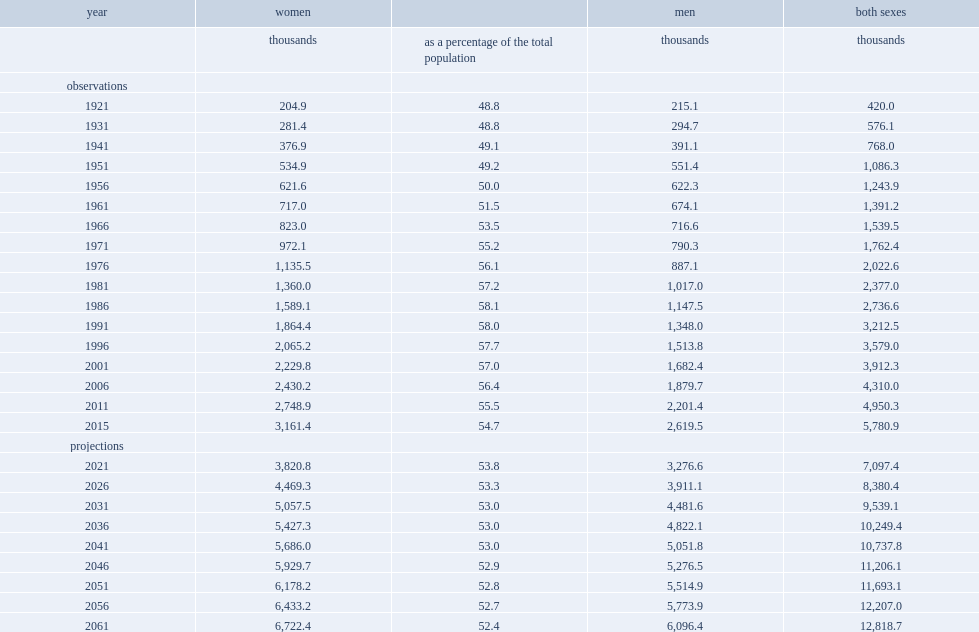What was the number of canada's seniors aged 65 and over were women? 3161.4. 3.2 million of canada's seniors aged 65 and over were women, how many percentage points did they account for in this age group? 54.7. By 2061, what was the number of seniors would be women? 6722.4. By 2061, 6.7 million of seniors would be women, how many percentage points did they account for of the senior population? 52.4. 